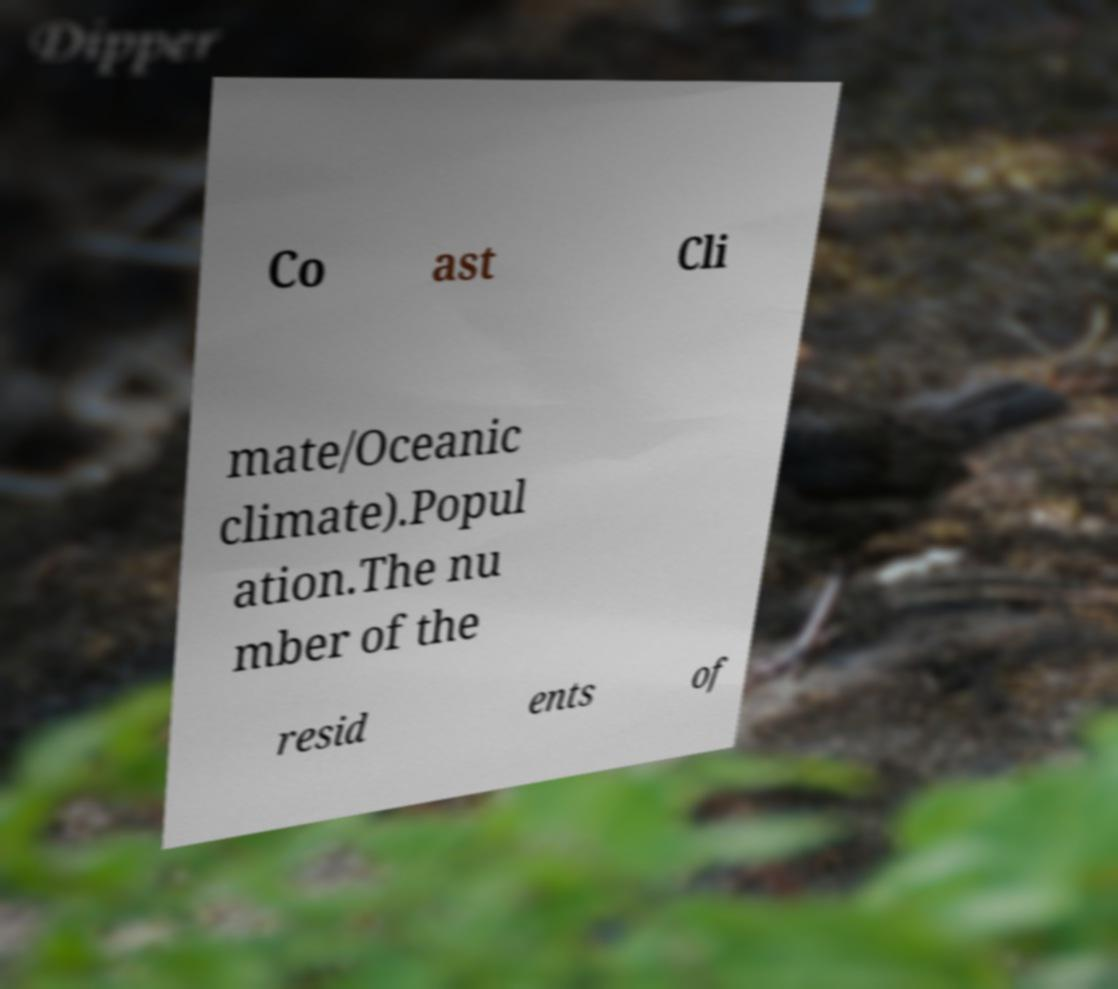What messages or text are displayed in this image? I need them in a readable, typed format. Co ast Cli mate/Oceanic climate).Popul ation.The nu mber of the resid ents of 